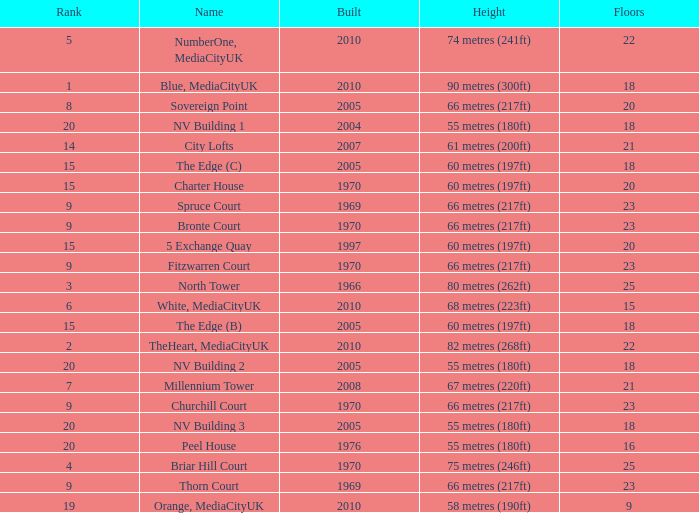What is the total number of Built, when Floors is less than 22, when Rank is less than 8, and when Name is White, Mediacityuk? 1.0. 